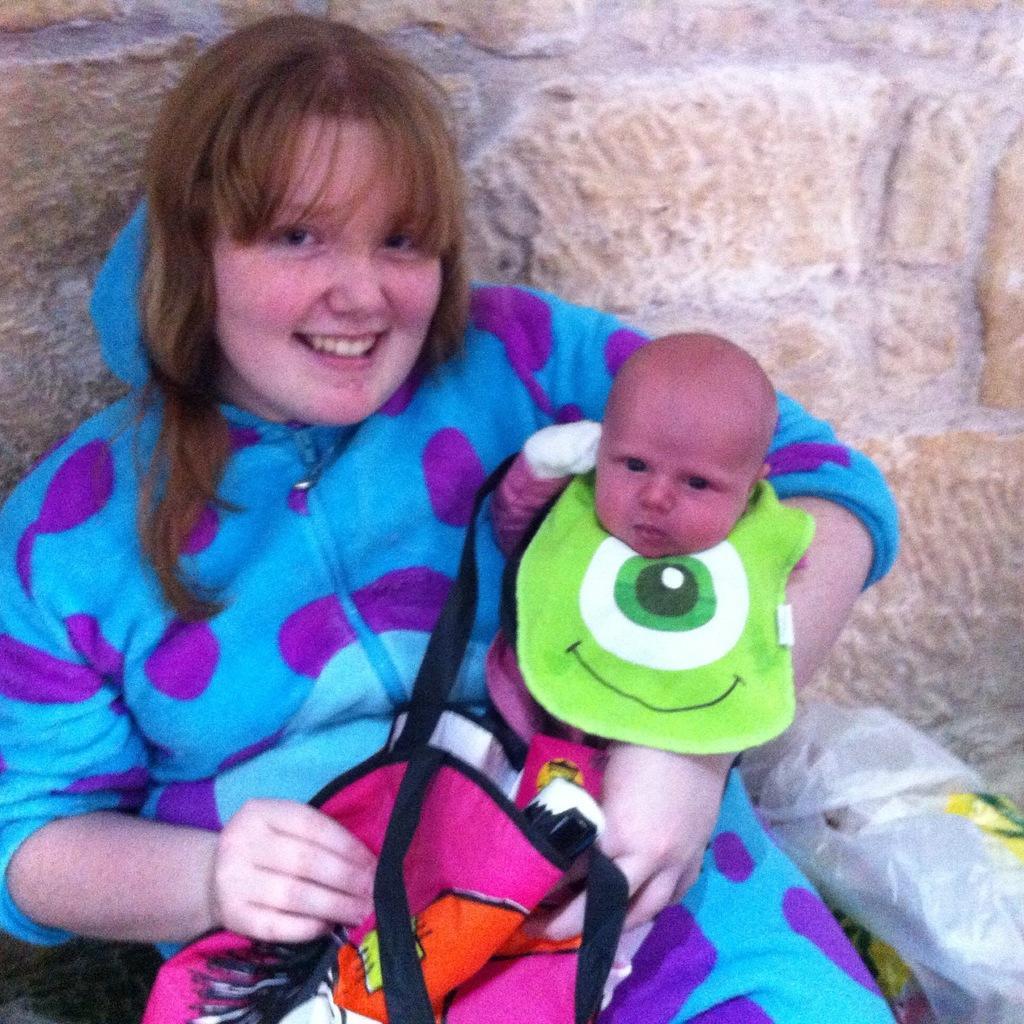Could you give a brief overview of what you see in this image? In this image, we can see a person wearing clothes and holding a baby with her hand. There is a plastic cover in the bottom right of the image. There is an object at the bottom of the image. In the background, we can see a wall. 